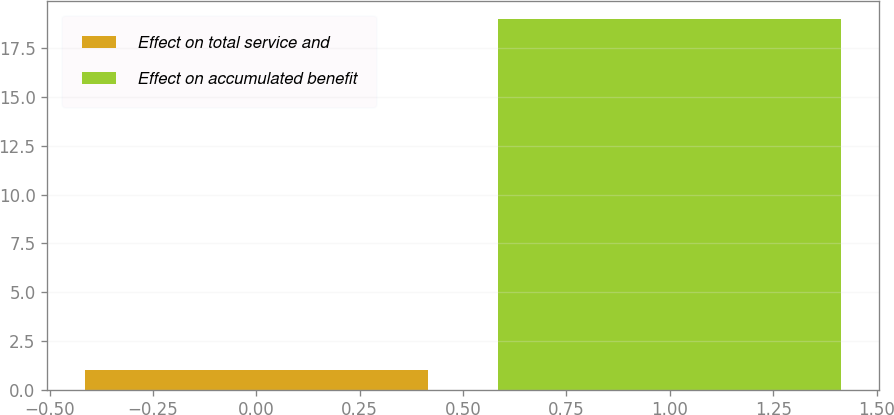Convert chart to OTSL. <chart><loc_0><loc_0><loc_500><loc_500><bar_chart><fcel>Effect on total service and<fcel>Effect on accumulated benefit<nl><fcel>1<fcel>19<nl></chart> 